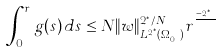<formula> <loc_0><loc_0><loc_500><loc_500>\int _ { 0 } ^ { r } g ( s ) \, d s \leq N \| w \| _ { L ^ { 2 ^ { * } } ( \Omega _ { r _ { 0 } } ) } ^ { 2 ^ { * } / N } r ^ { \frac { q - 2 ^ { * } } { q } }</formula> 